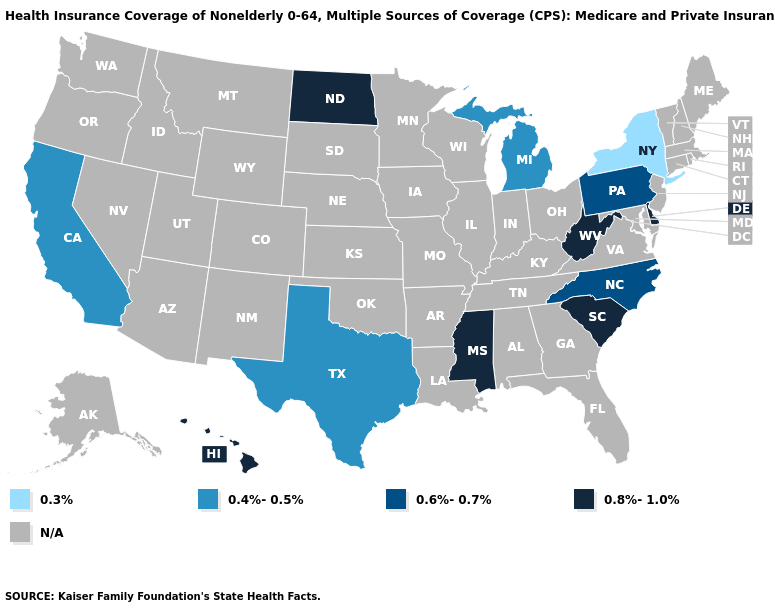Name the states that have a value in the range 0.8%-1.0%?
Short answer required. Delaware, Hawaii, Mississippi, North Dakota, South Carolina, West Virginia. What is the highest value in the USA?
Quick response, please. 0.8%-1.0%. What is the value of Massachusetts?
Keep it brief. N/A. Name the states that have a value in the range 0.4%-0.5%?
Be succinct. California, Michigan, Texas. Name the states that have a value in the range N/A?
Quick response, please. Alabama, Alaska, Arizona, Arkansas, Colorado, Connecticut, Florida, Georgia, Idaho, Illinois, Indiana, Iowa, Kansas, Kentucky, Louisiana, Maine, Maryland, Massachusetts, Minnesota, Missouri, Montana, Nebraska, Nevada, New Hampshire, New Jersey, New Mexico, Ohio, Oklahoma, Oregon, Rhode Island, South Dakota, Tennessee, Utah, Vermont, Virginia, Washington, Wisconsin, Wyoming. Name the states that have a value in the range 0.6%-0.7%?
Give a very brief answer. North Carolina, Pennsylvania. Name the states that have a value in the range 0.8%-1.0%?
Quick response, please. Delaware, Hawaii, Mississippi, North Dakota, South Carolina, West Virginia. Name the states that have a value in the range N/A?
Keep it brief. Alabama, Alaska, Arizona, Arkansas, Colorado, Connecticut, Florida, Georgia, Idaho, Illinois, Indiana, Iowa, Kansas, Kentucky, Louisiana, Maine, Maryland, Massachusetts, Minnesota, Missouri, Montana, Nebraska, Nevada, New Hampshire, New Jersey, New Mexico, Ohio, Oklahoma, Oregon, Rhode Island, South Dakota, Tennessee, Utah, Vermont, Virginia, Washington, Wisconsin, Wyoming. Name the states that have a value in the range N/A?
Short answer required. Alabama, Alaska, Arizona, Arkansas, Colorado, Connecticut, Florida, Georgia, Idaho, Illinois, Indiana, Iowa, Kansas, Kentucky, Louisiana, Maine, Maryland, Massachusetts, Minnesota, Missouri, Montana, Nebraska, Nevada, New Hampshire, New Jersey, New Mexico, Ohio, Oklahoma, Oregon, Rhode Island, South Dakota, Tennessee, Utah, Vermont, Virginia, Washington, Wisconsin, Wyoming. What is the value of Idaho?
Keep it brief. N/A. Which states have the highest value in the USA?
Short answer required. Delaware, Hawaii, Mississippi, North Dakota, South Carolina, West Virginia. Name the states that have a value in the range 0.6%-0.7%?
Be succinct. North Carolina, Pennsylvania. Does California have the highest value in the USA?
Write a very short answer. No. Is the legend a continuous bar?
Keep it brief. No. What is the value of California?
Give a very brief answer. 0.4%-0.5%. 